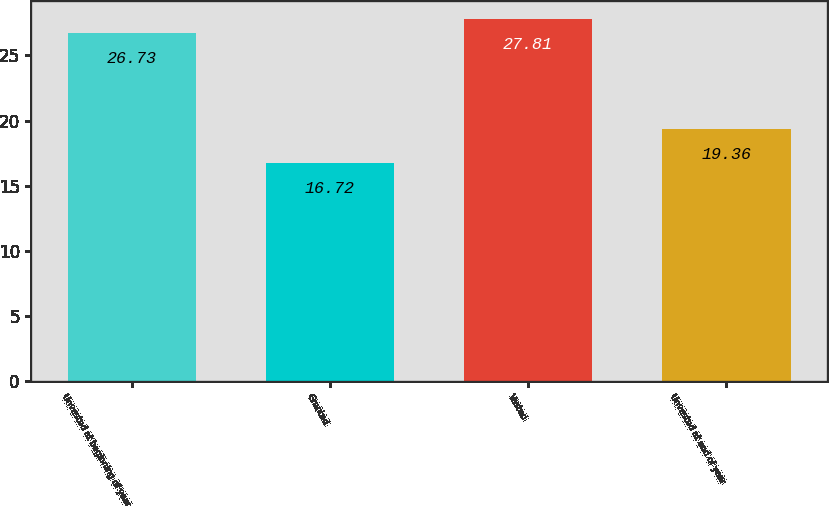<chart> <loc_0><loc_0><loc_500><loc_500><bar_chart><fcel>Unvested at beginning of year<fcel>Granted<fcel>Vested<fcel>Unvested at end of year<nl><fcel>26.73<fcel>16.72<fcel>27.81<fcel>19.36<nl></chart> 